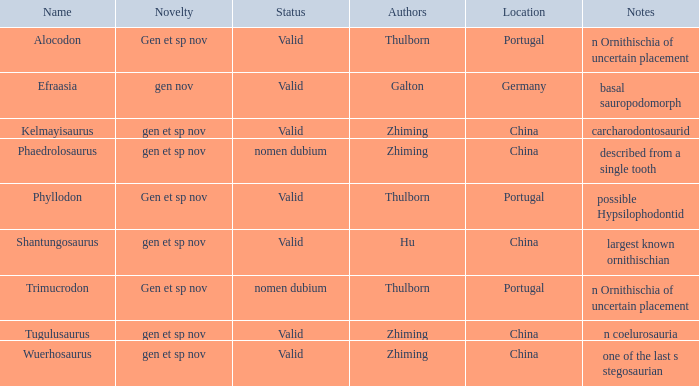What is the Name of the dinosaur that was discovered in the Location, China, and whose Notes are, "described from a single tooth"? Phaedrolosaurus. 